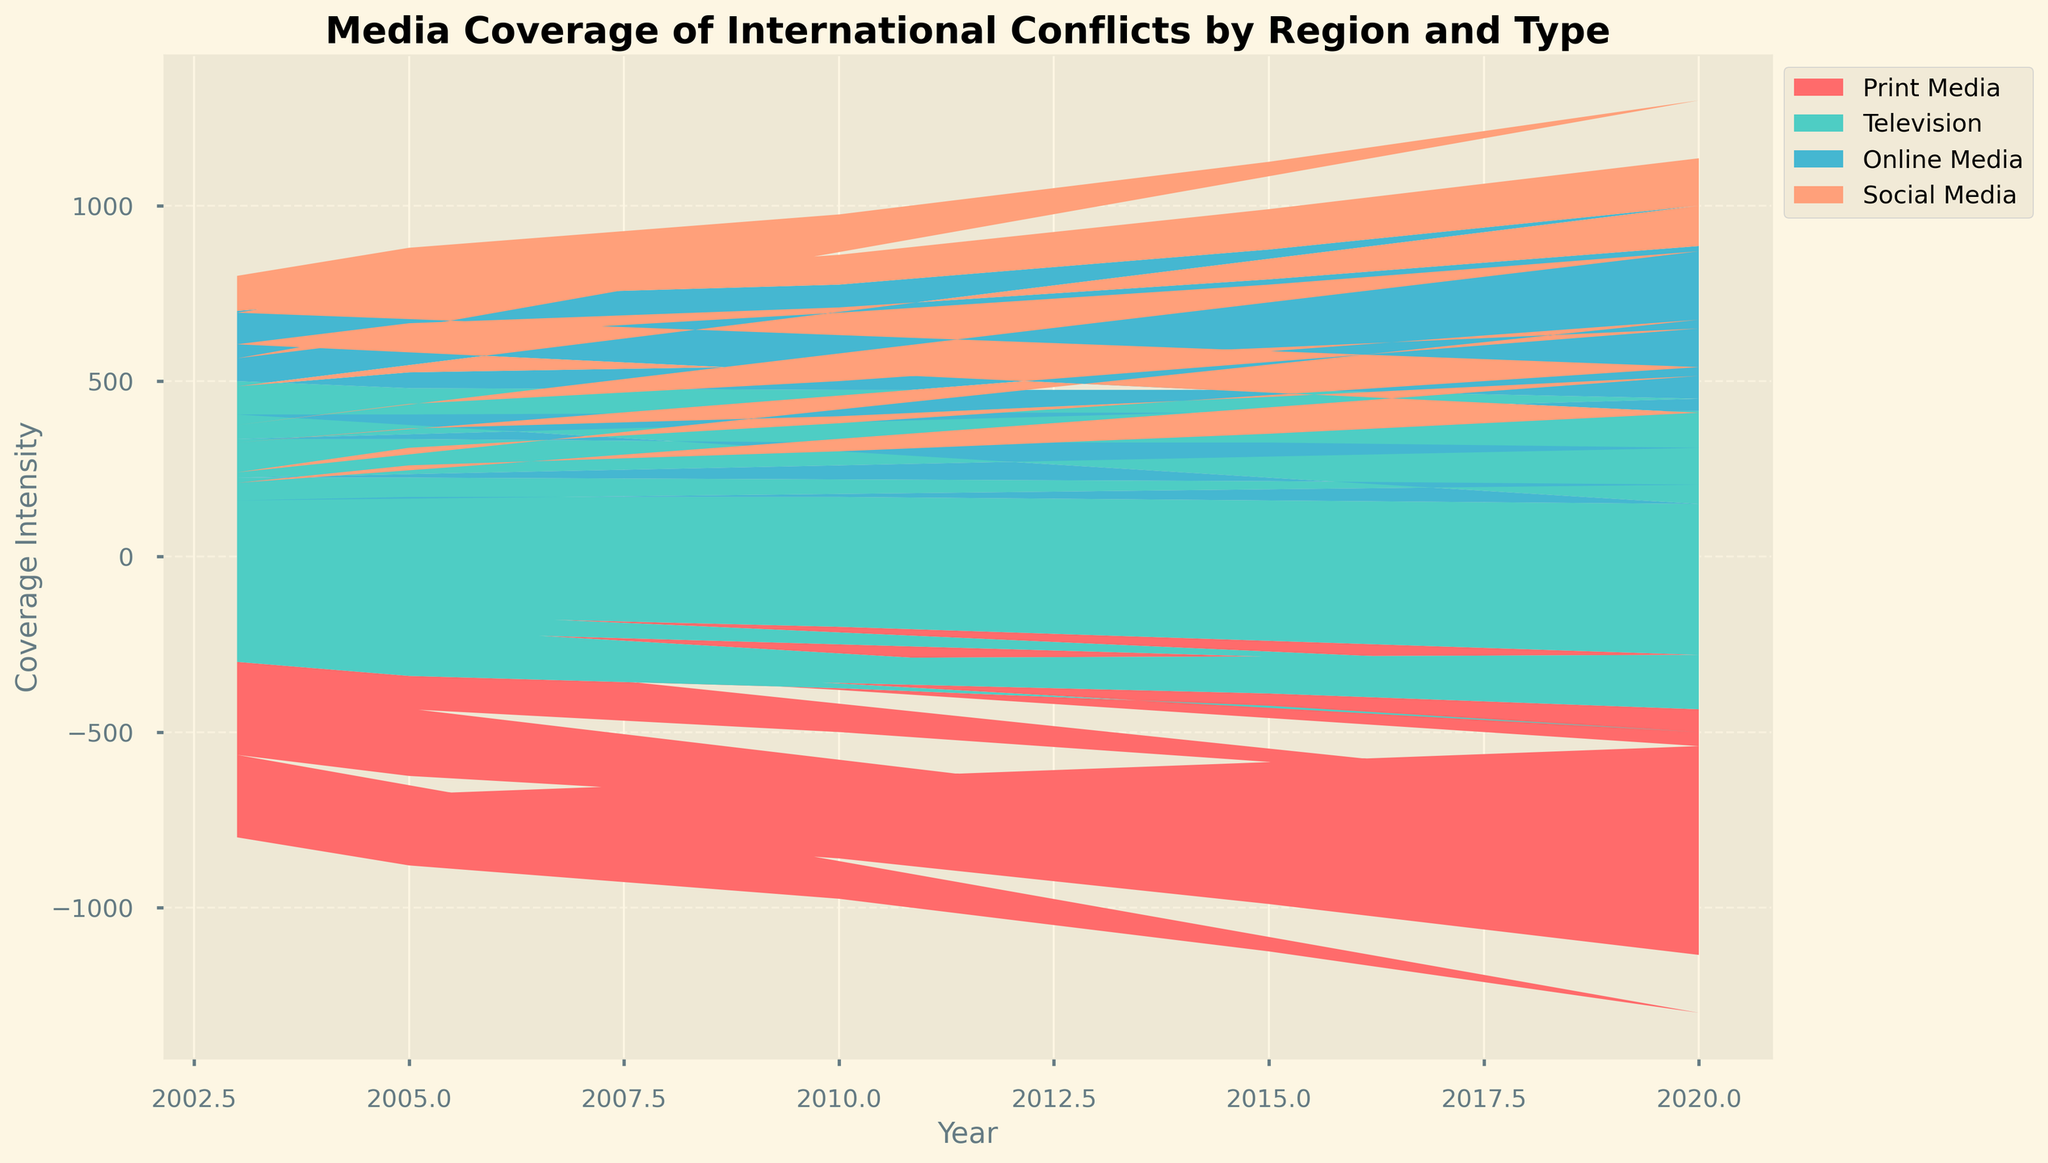What is the title of the figure? The title of the figure is typically found at the top of the chart.
Answer: Media Coverage of International Conflicts by Region and Type Which region had the highest overall media coverage in 2020? To find the highest overall media coverage by region, sum the media types for each region in 2020 and compare. The Middle East has the highest sum (800 + 950 + 550 + 300).
Answer: Middle East How did online media coverage in Africa change from 2005 to 2020? Subtract the 2005 online media coverage in Africa from the 2020 value: 310 - 140 = 170.
Answer: Increased by 170 Between Print Media and Online Media in Europe during 2010, which had higher coverage? Compare the coverage values for Print Media and Online Media in Europe in 2010: 350 (Print Media) vs. 220 (Online Media).
Answer: Print Media Which media type had the largest increase in coverage in the Middle East from 2010 to 2020? Calculate the increase for each media type: Print Media (800-600=200), Television (950-850=100), Online Media (550-300=250), Social Media (300-200=100). The Online Media had the largest increase.
Answer: Online Media What is the difference in social media coverage in Latin America between 2015 and 2020? Subtract the 2015 value from the 2020 value for Social Media in Latin America: 250 - 200 = 50.
Answer: 50 In which year did print media coverage in Asia exceed 200 for the first time? Look for the first year when the Print Media coverage in Asia is over 200. This happens in 2015 with a value of 220.
Answer: 2015 How does the overall trend in social media coverage compare between Europe and Latin America over the 20 years? Observe and compare the trend lines for social media coverage in Europe and Latin America. Both show an increasing trend, but Latin America has a more rapid increase compared to Europe.
Answer: Both increased, Latin America more rapidly Which type of media showed the smallest increase in coverage in Africa from 2003 to 2020? Calculate the increase for each media type in Africa: Print Media (350-200=150), Television (530-400=130), Online Media (310-100=210), Social Media (160-50=110). Television has the smallest increase.
Answer: Television Did television media coverage in the Middle East ever decrease in the past 20 years? Observe the trend line for Television media coverage in the Middle East. The coverage consistently rises from 800 in 2003 to 950 in 2020.
Answer: No 